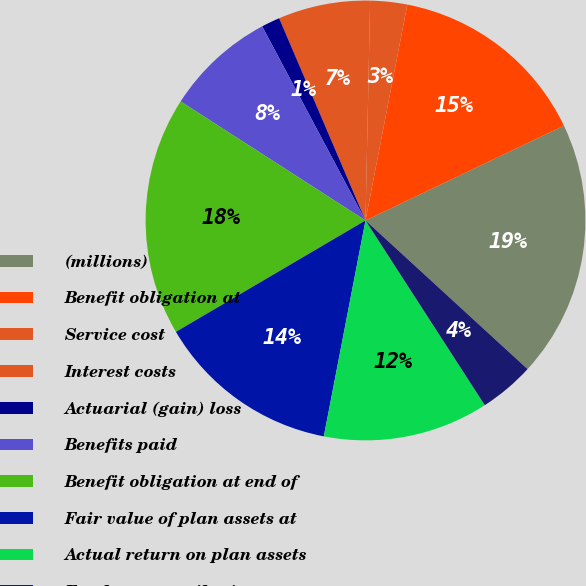Convert chart to OTSL. <chart><loc_0><loc_0><loc_500><loc_500><pie_chart><fcel>(millions)<fcel>Benefit obligation at<fcel>Service cost<fcel>Interest costs<fcel>Actuarial (gain) loss<fcel>Benefits paid<fcel>Benefit obligation at end of<fcel>Fair value of plan assets at<fcel>Actual return on plan assets<fcel>Employer contributions<nl><fcel>18.91%<fcel>14.86%<fcel>2.71%<fcel>6.76%<fcel>1.36%<fcel>8.11%<fcel>17.56%<fcel>13.51%<fcel>12.16%<fcel>4.06%<nl></chart> 